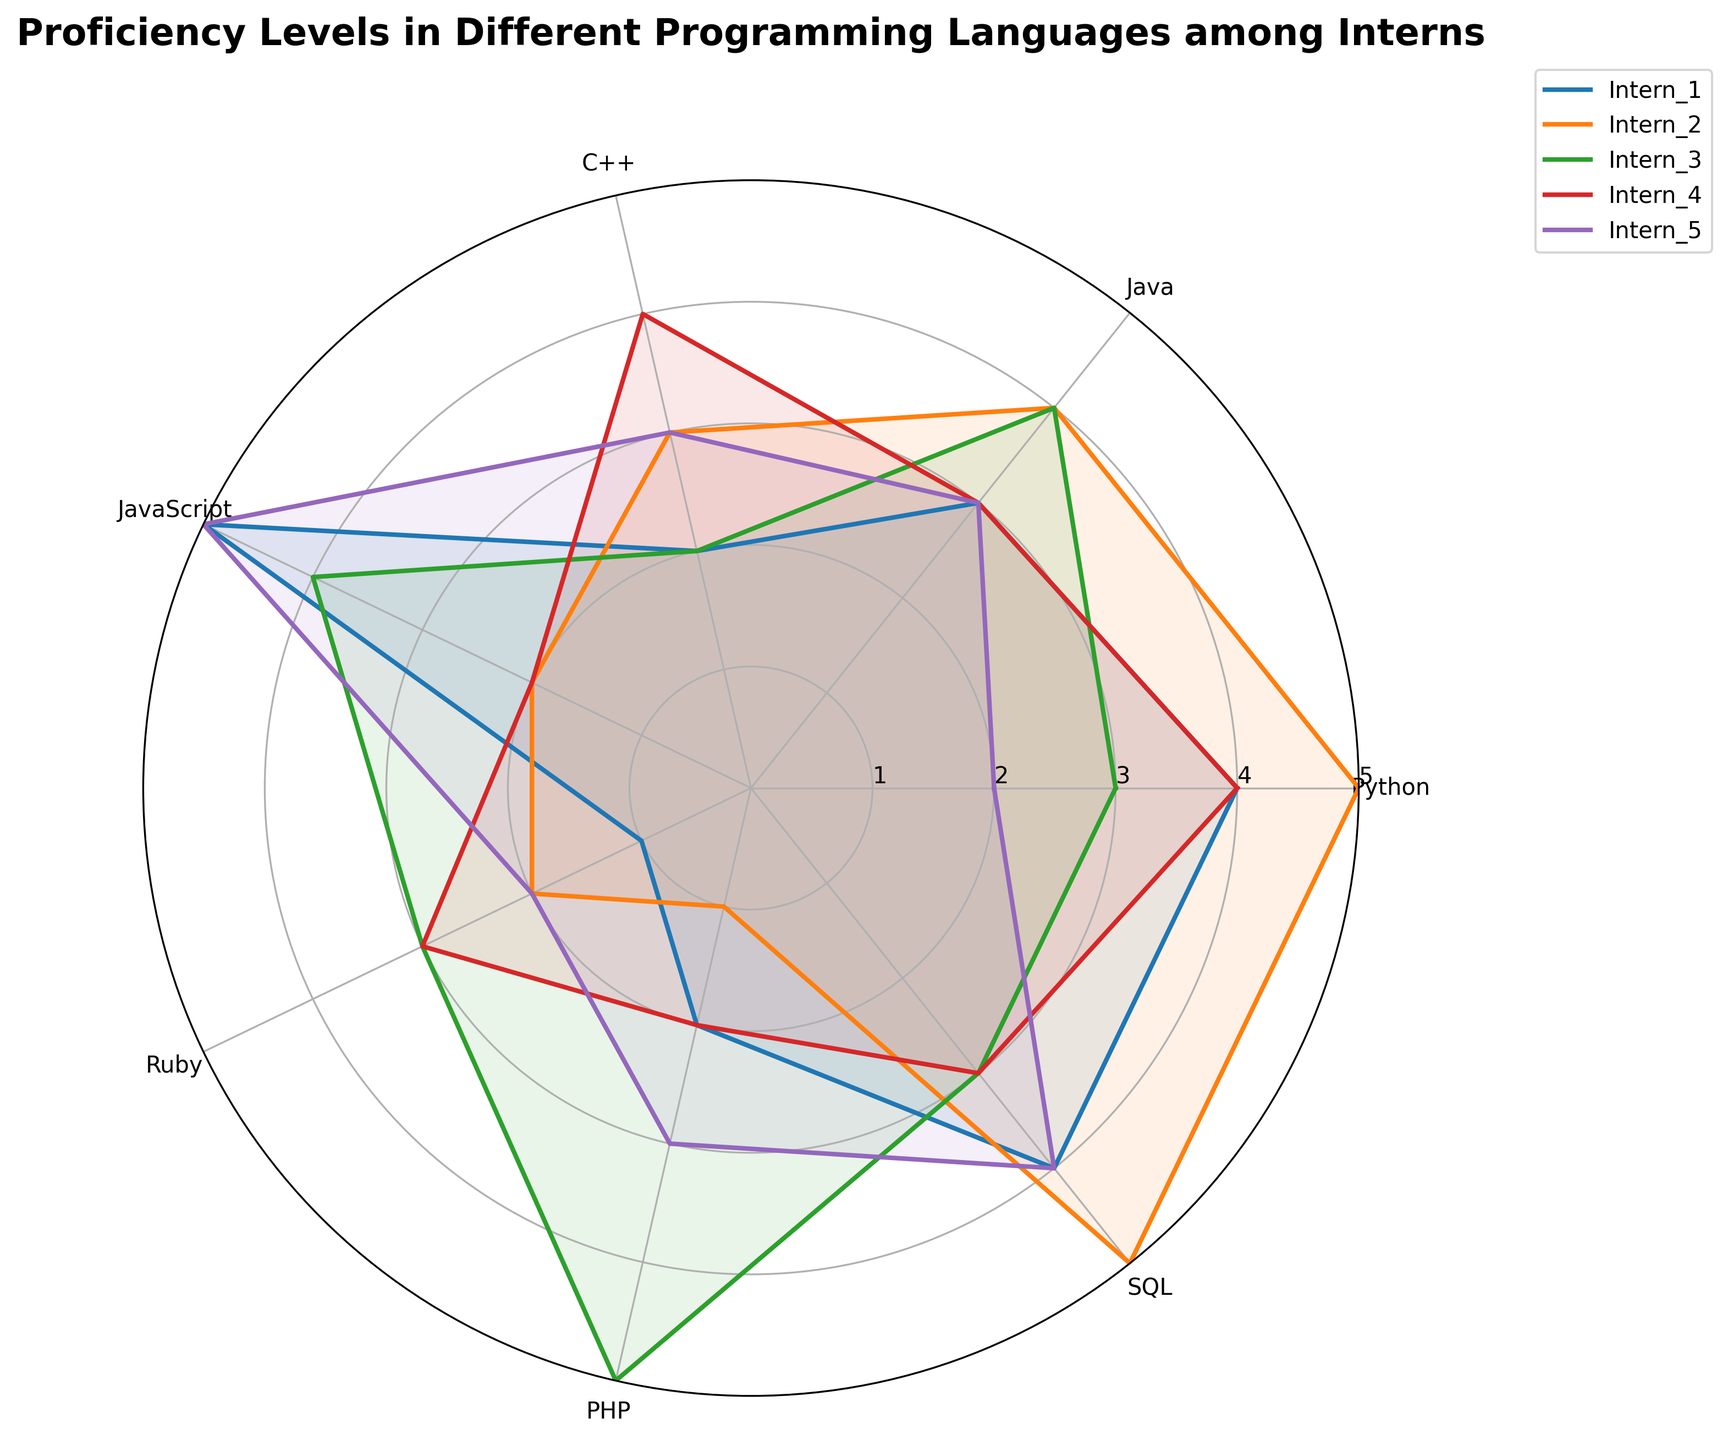What's the title of the figure? The title of the figure is displayed prominently at the top of the radar chart. By checking the top part, we see the phrase "Proficiency Levels in Different Programming Languages among Interns".
Answer: Proficiency Levels in Different Programming Languages among Interns What are the yticks labeled with? The yticks in the radar chart represent proficiency levels and are labeled ranging from 1 to 5.
Answer: 1 to 5 How many proficiency levels does Intern_1 have a score of 4 or higher? By checking the radar chart, we look at each point for Intern_1. There are three proficiency levels where the score is 4 or higher: Python (4), JavaScript (5), and SQL (4).
Answer: 3 Which intern has the highest proficiency in PHP? Observing the values on the radar chart, we see that Intern_3 has the highest PHP proficiency level at 5.
Answer: Intern_3 Compare the proficiency levels of Intern_2 and Intern_4 in Python and determine who is more proficient. Intern_2 has a proficiency of 5 in Python, while Intern_4 has a proficiency of 4 in Python. Therefore, Intern_2 is more proficient in Python.
Answer: Intern_2 Which programming language do most interns have the highest proficiency in? Examining the radar chart, we look for the programming language where the highest scores are most frequently achieved. JavaScript has two scores of 5 (Intern_1 and Intern_5), which is the highest frequency.
Answer: JavaScript Calculate the average proficiency level of Intern_3 across all programming languages. The proficiency levels for Intern_3 are Python (3), Java (4), C++ (2), JavaScript (4), Ruby (3), PHP (5), SQL (3). Summing these, we get 24. Dividing by the number of languages (7), the average is 24/7.
Answer: 3.43 (rounded to two decimal places) Which programming language has the largest discrepancy in proficiency levels among interns? By observing the radar chart, we can see which programming language has the highest variation in proficiency scores. PHP has the most significant discrepancy, with scores ranging from 1 to 5.
Answer: PHP 